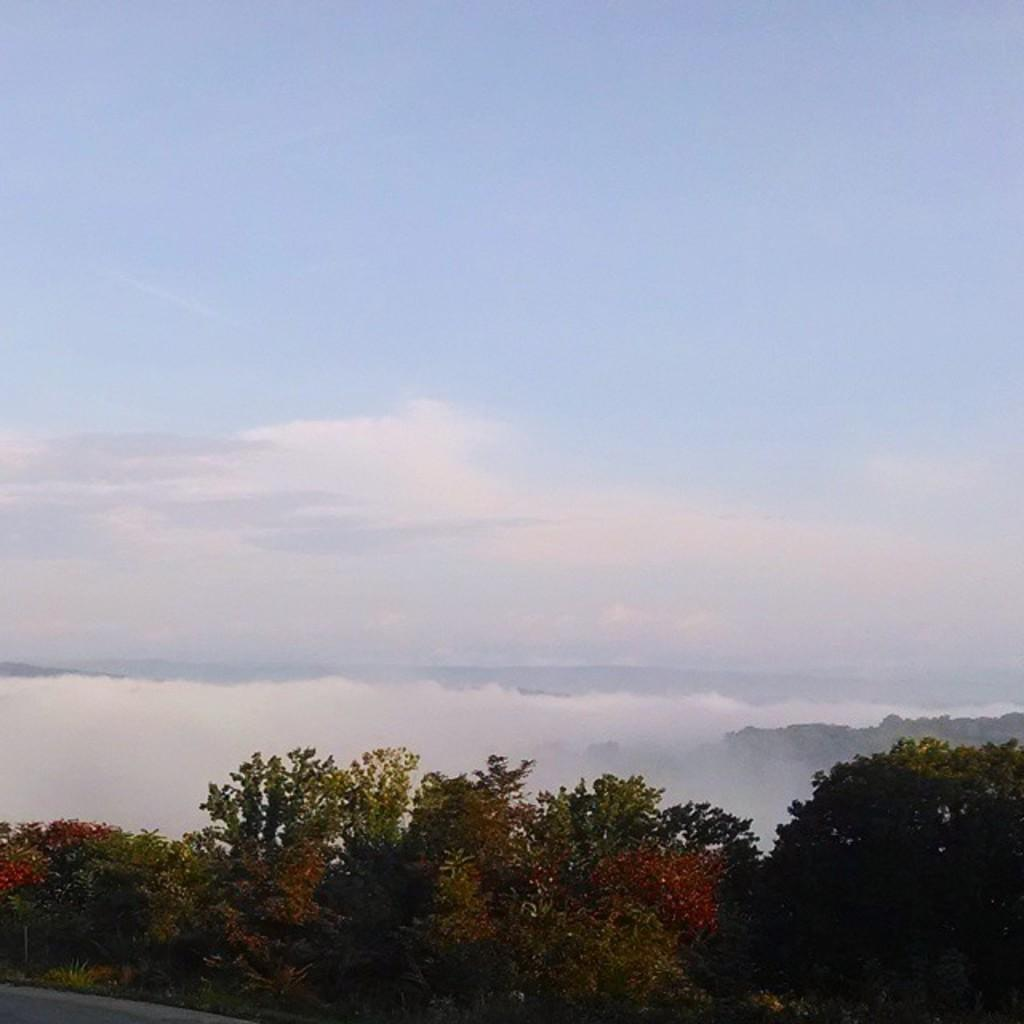What is present in the image that is liquid? There is water in the image. What type of vegetation can be seen in the image? There are trees in the image. What is the condition of the sky in the image? The sky is cloudy in the image. What type of gold object is visible in the image? There is no gold object present in the image. Is there a flag flying in the image? There is no flag present in the image. 